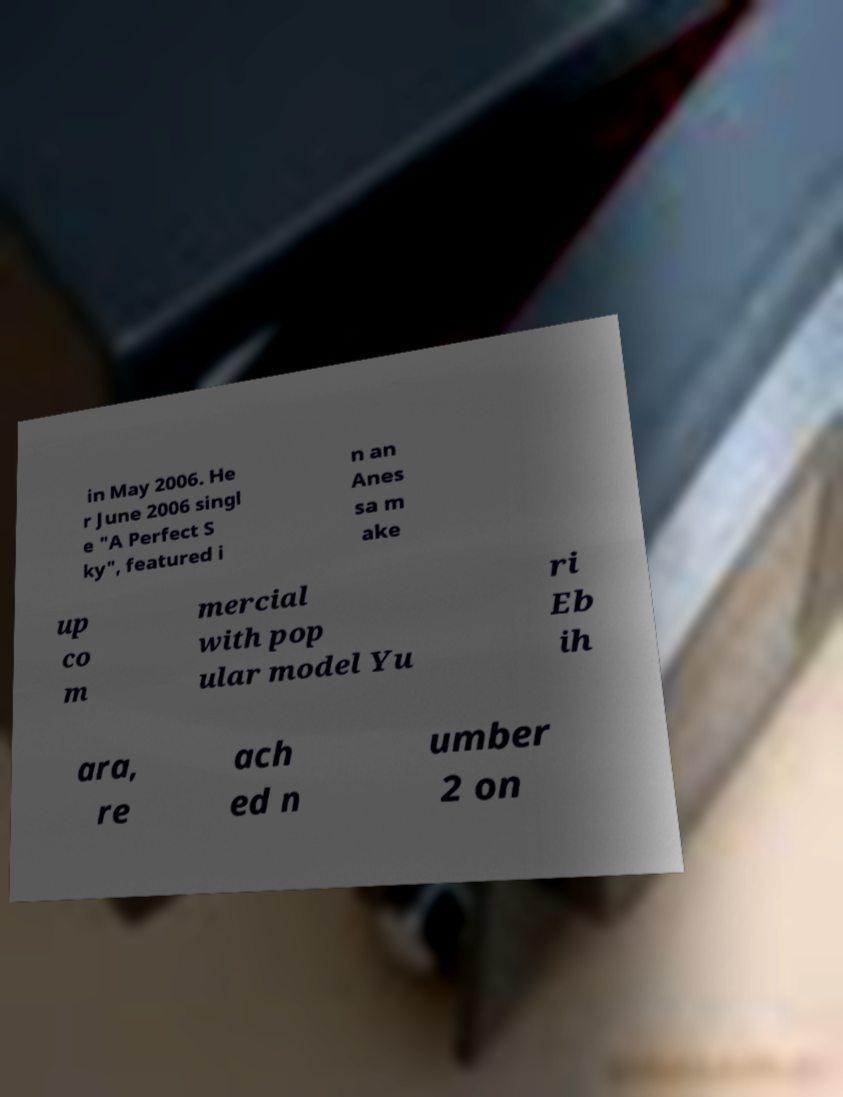Please read and relay the text visible in this image. What does it say? in May 2006. He r June 2006 singl e "A Perfect S ky", featured i n an Anes sa m ake up co m mercial with pop ular model Yu ri Eb ih ara, re ach ed n umber 2 on 